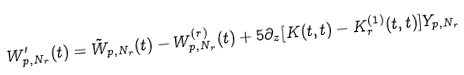Convert formula to latex. <formula><loc_0><loc_0><loc_500><loc_500>W _ { p , N _ { r } } ^ { \prime } ( t ) = \tilde { W } _ { p , N _ { r } } ( t ) - W _ { p , N _ { r } } ^ { ( r ) } ( t ) + 5 \partial _ { z } [ K ( t , t ) - K _ { r } ^ { ( 1 ) } ( t , t ) ] Y _ { p , N _ { r } }</formula> 